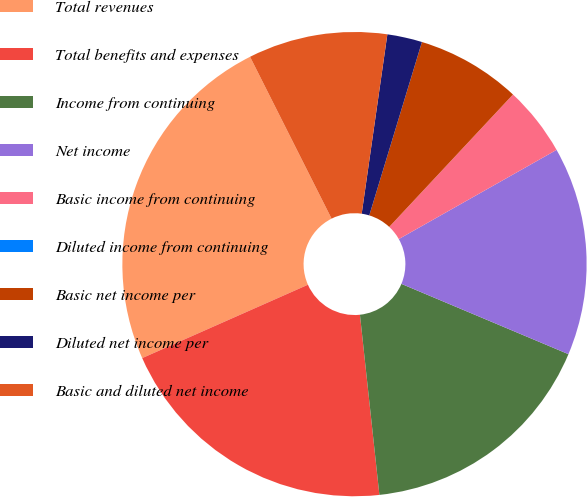<chart> <loc_0><loc_0><loc_500><loc_500><pie_chart><fcel>Total revenues<fcel>Total benefits and expenses<fcel>Income from continuing<fcel>Net income<fcel>Basic income from continuing<fcel>Diluted income from continuing<fcel>Basic net income per<fcel>Diluted net income per<fcel>Basic and diluted net income<nl><fcel>24.21%<fcel>20.08%<fcel>16.95%<fcel>14.53%<fcel>4.85%<fcel>0.0%<fcel>7.27%<fcel>2.43%<fcel>9.69%<nl></chart> 